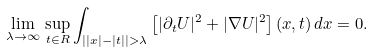<formula> <loc_0><loc_0><loc_500><loc_500>\lim _ { \lambda \to \infty } \, \sup _ { t \in R } \int _ { \left | | x | - | t | \right | > \lambda } \left [ | \partial _ { t } U | ^ { 2 } + | \nabla U | ^ { 2 } \right ] ( x , t ) \, d x = 0 .</formula> 